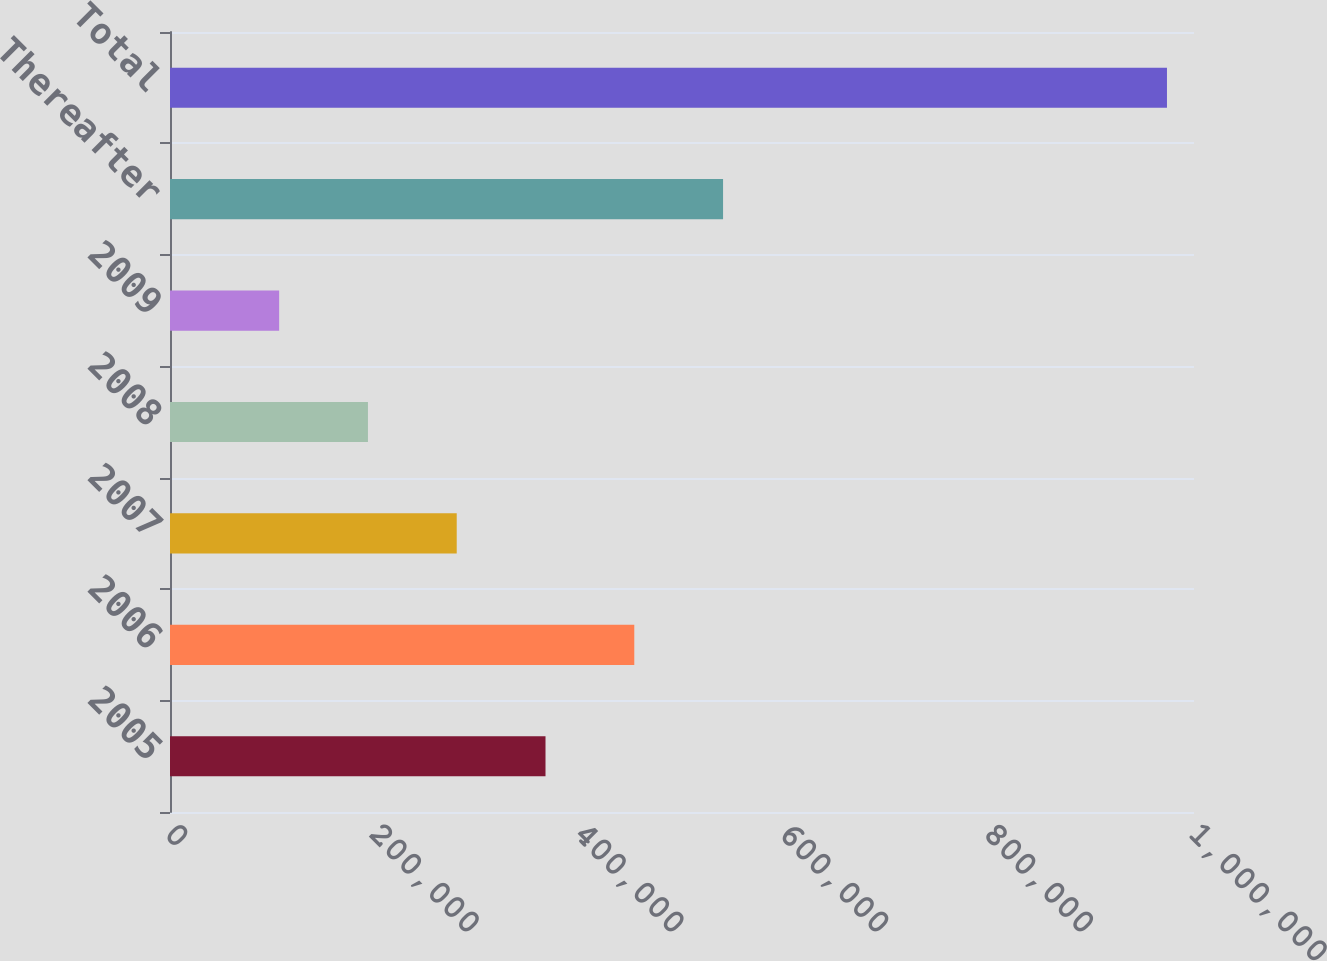Convert chart. <chart><loc_0><loc_0><loc_500><loc_500><bar_chart><fcel>2005<fcel>2006<fcel>2007<fcel>2008<fcel>2009<fcel>Thereafter<fcel>Total<nl><fcel>366700<fcel>453400<fcel>280000<fcel>193299<fcel>106599<fcel>540100<fcel>973602<nl></chart> 